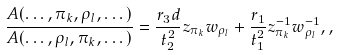<formula> <loc_0><loc_0><loc_500><loc_500>\frac { A ( \dots , \pi _ { k } , \rho _ { l } , \dots ) } { A ( \dots , \rho _ { l } , \pi _ { k } , \dots ) } = \frac { r _ { 3 } d } { t _ { 2 } ^ { 2 } } z _ { \pi _ { k } } w _ { \rho _ { l } } + \frac { r _ { 1 } } { t _ { 1 } ^ { 2 } } z _ { \pi _ { k } } ^ { - 1 } w _ { \rho _ { l } } ^ { - 1 } , ,</formula> 